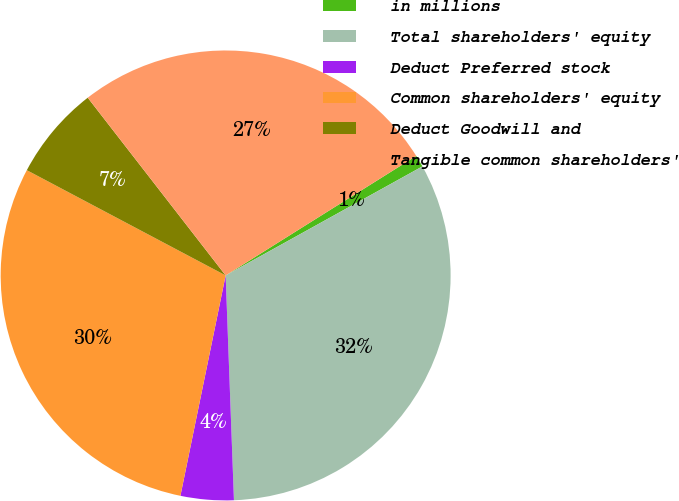Convert chart. <chart><loc_0><loc_0><loc_500><loc_500><pie_chart><fcel>in millions<fcel>Total shareholders' equity<fcel>Deduct Preferred stock<fcel>Common shareholders' equity<fcel>Deduct Goodwill and<fcel>Tangible common shareholders'<nl><fcel>0.86%<fcel>32.47%<fcel>3.81%<fcel>29.53%<fcel>6.75%<fcel>26.59%<nl></chart> 